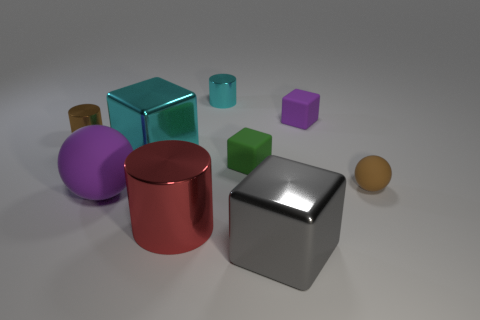What is the color of the cylinder in front of the small brown cylinder? red 